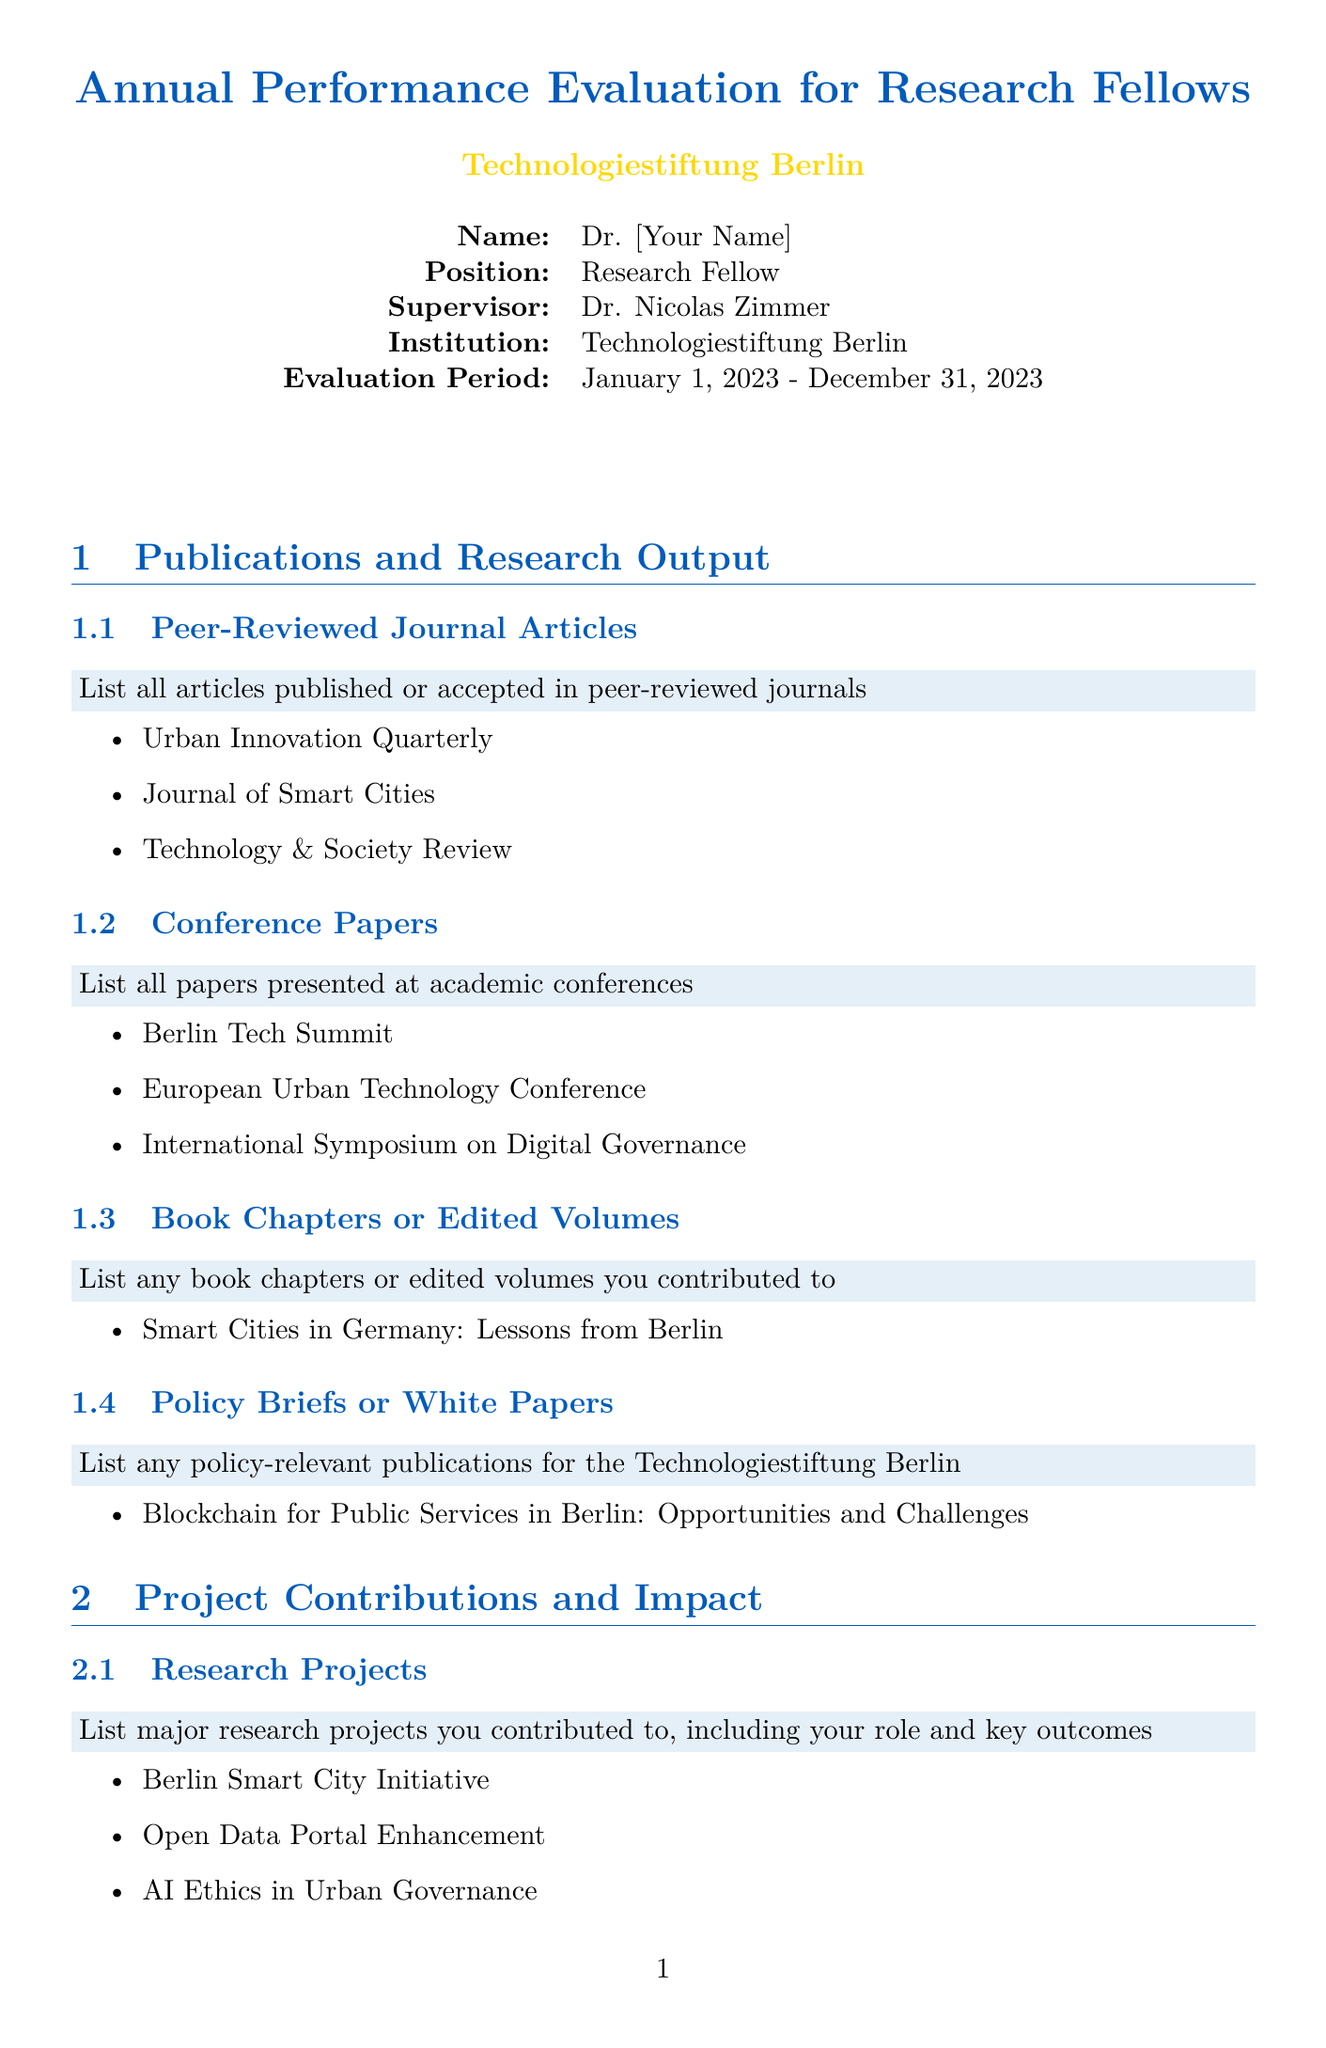What is the title of the form? The title of the form is stated at the top of the document, indicating the purpose of the evaluation.
Answer: Annual Performance Evaluation for Research Fellows Who is the researcher being evaluated? The document specifies the name of the researcher at the beginning under researcher info.
Answer: Dr. [Your Name] What is the evaluation period? The evaluation period is mentioned in the researcher information section.
Answer: January 1, 2023 - December 31, 2023 Name one example of a peer-reviewed journal article. The document lists examples of peer-reviewed journal articles in the publications section.
Answer: Urban Innovation Quarterly What type of projects are listed under the contributions section? This section outlines the research project contributions made by the fellow, capturing the subject matter of involvement.
Answer: Research Projects What is one area for skill development mentioned? The document includes a subsection outlining areas where the researcher aims to grow professionally.
Answer: Advanced data visualization techniques Who completes the overall performance assessment? The document indicates in the section for feedback that a specific individual is responsible for this evaluation.
Answer: Dr. Nicolas Zimmer What kind of publication is "Blockchain for Public Services in Berlin"? The document categorizes this publication under a specific type of output in the publications section.
Answer: Policy Briefs or White Papers 